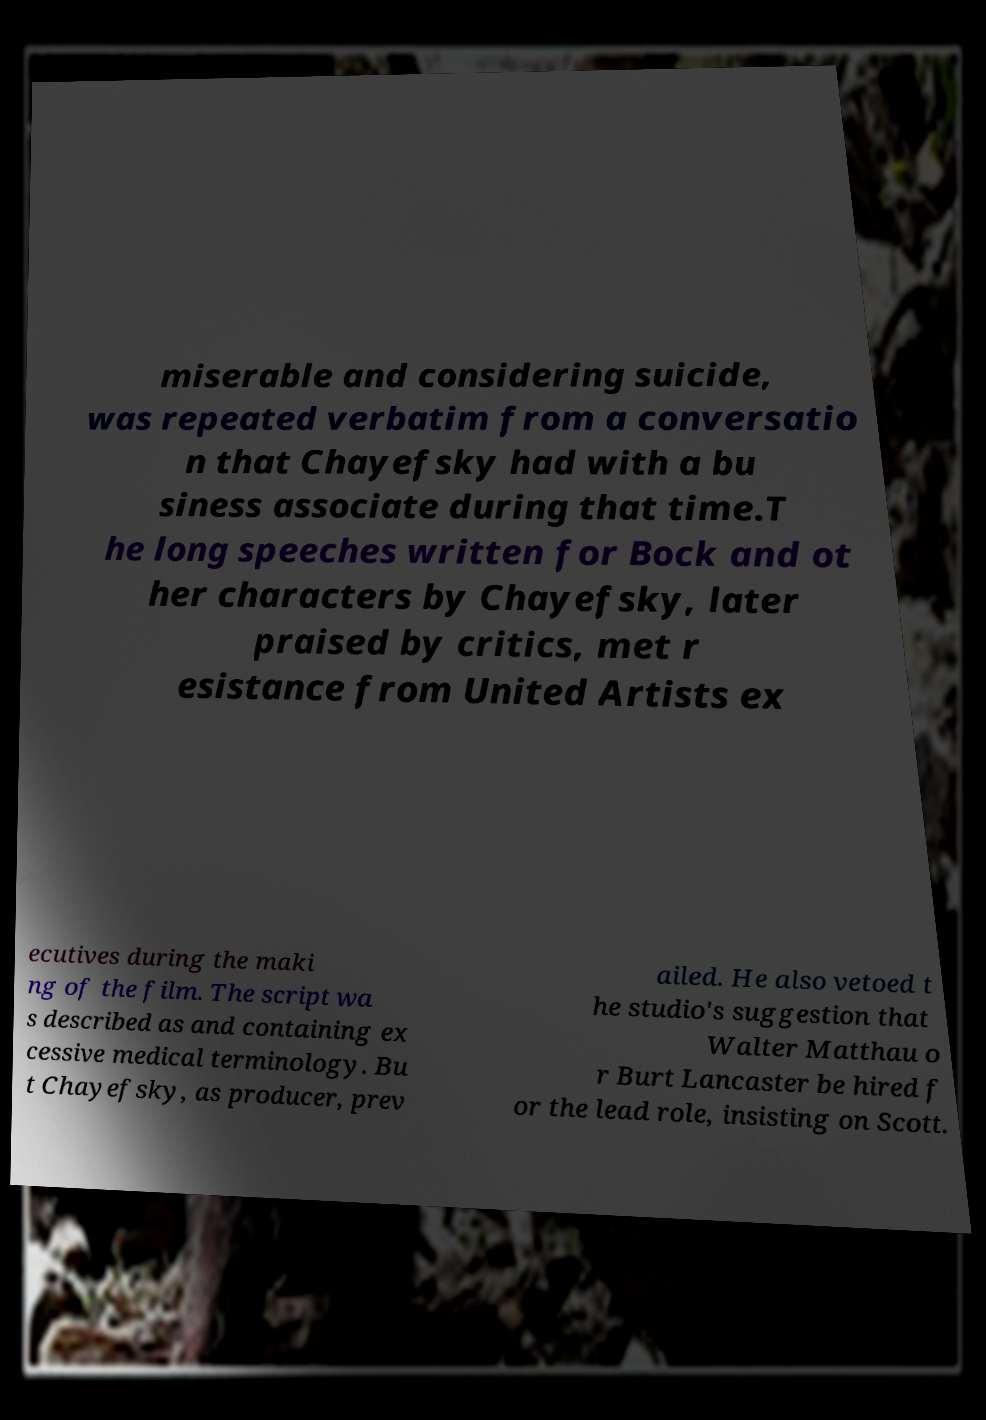I need the written content from this picture converted into text. Can you do that? miserable and considering suicide, was repeated verbatim from a conversatio n that Chayefsky had with a bu siness associate during that time.T he long speeches written for Bock and ot her characters by Chayefsky, later praised by critics, met r esistance from United Artists ex ecutives during the maki ng of the film. The script wa s described as and containing ex cessive medical terminology. Bu t Chayefsky, as producer, prev ailed. He also vetoed t he studio's suggestion that Walter Matthau o r Burt Lancaster be hired f or the lead role, insisting on Scott. 